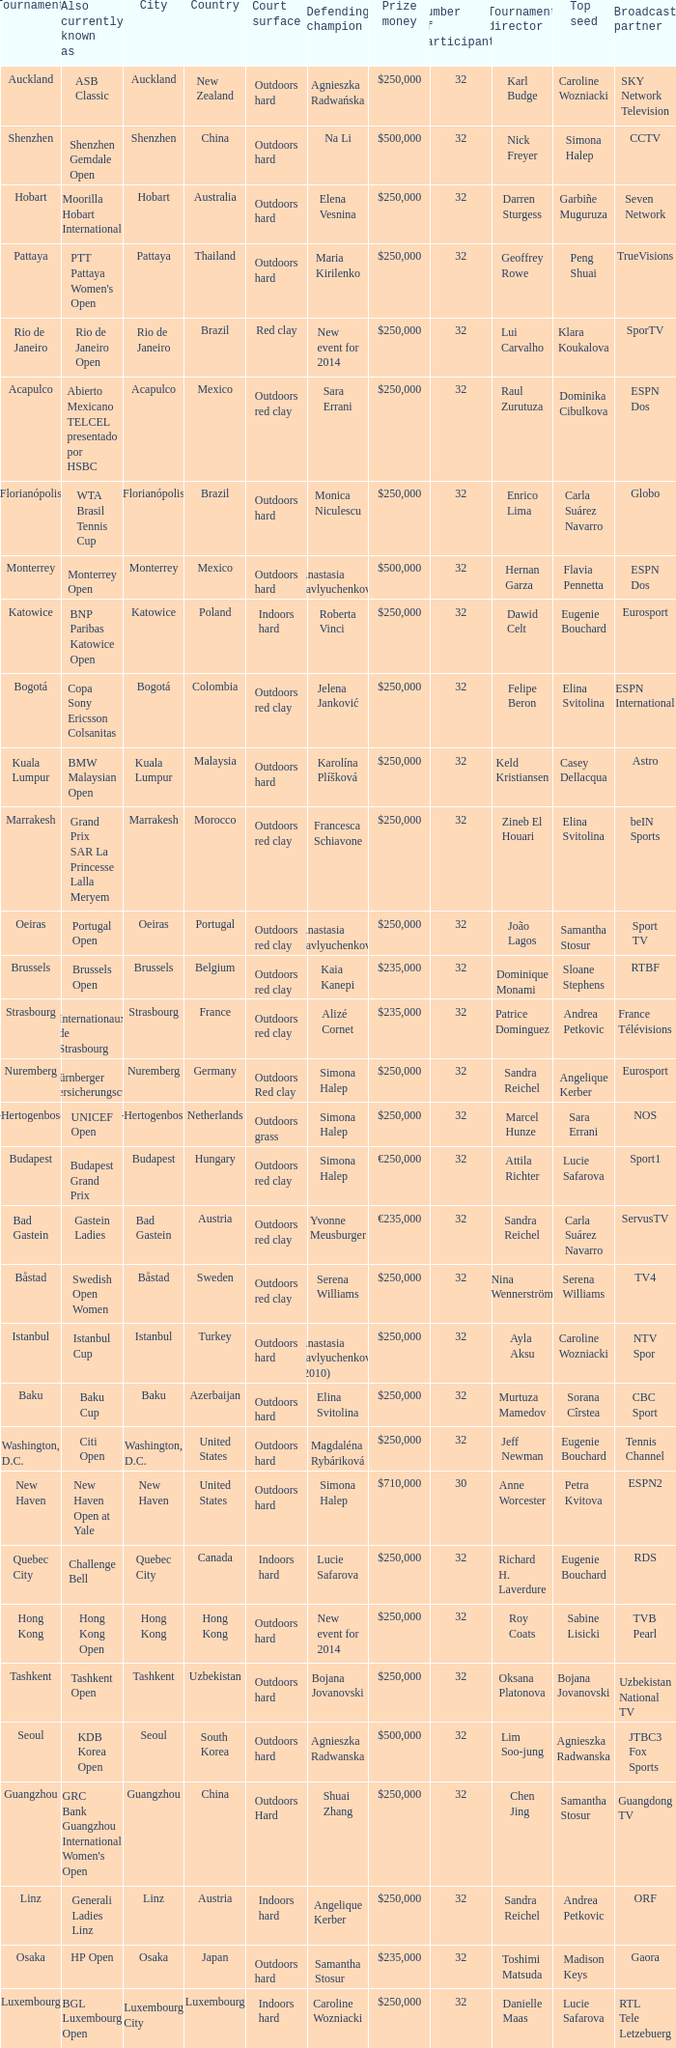How many tournaments are also currently known as the hp open? 1.0. 